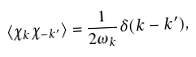Convert formula to latex. <formula><loc_0><loc_0><loc_500><loc_500>\langle { \chi } _ { k } { \chi } _ { - k ^ { \prime } } \rangle = \frac { 1 } { 2 { \omega } _ { k } } \delta ( k - k ^ { \prime } ) ,</formula> 